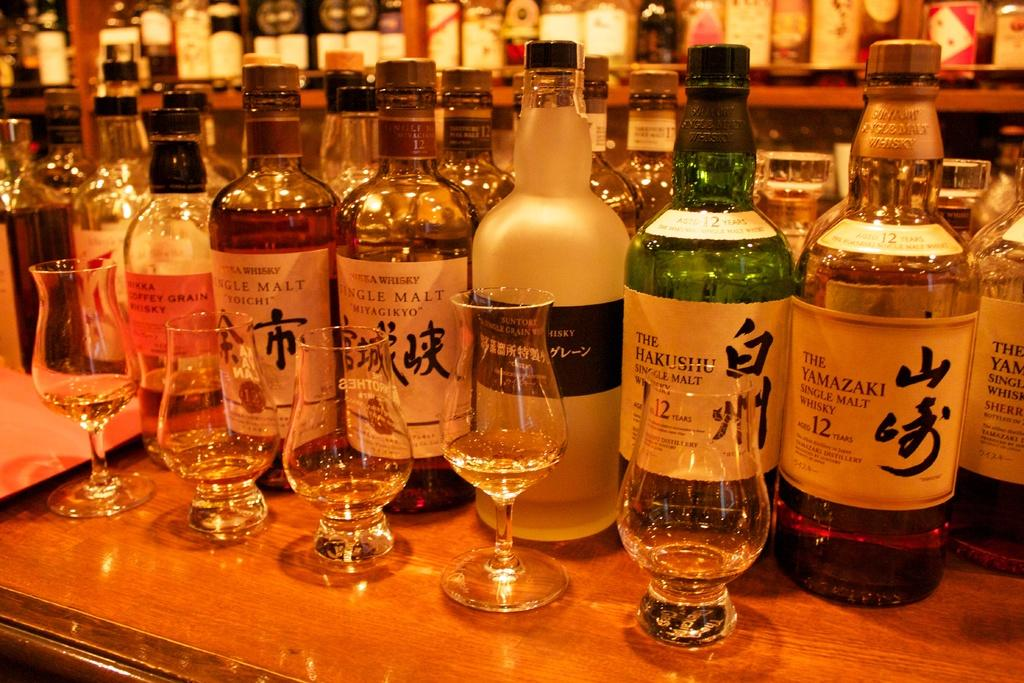<image>
Create a compact narrative representing the image presented. a Japanese liquor collection with drinking glasses at a bar. 